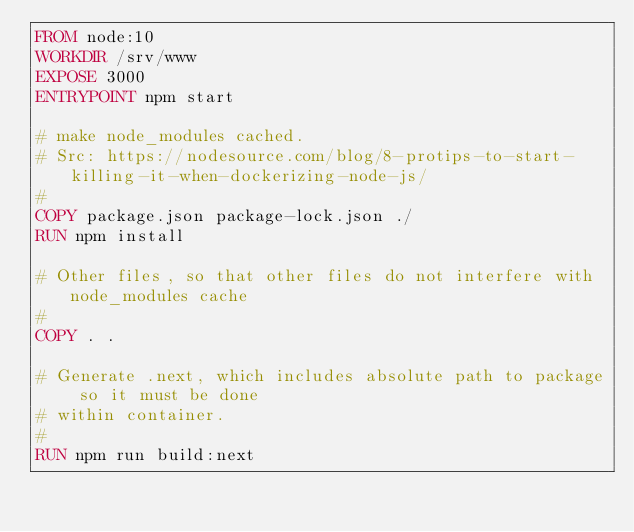Convert code to text. <code><loc_0><loc_0><loc_500><loc_500><_Dockerfile_>FROM node:10
WORKDIR /srv/www
EXPOSE 3000
ENTRYPOINT npm start

# make node_modules cached.
# Src: https://nodesource.com/blog/8-protips-to-start-killing-it-when-dockerizing-node-js/
#
COPY package.json package-lock.json ./
RUN npm install

# Other files, so that other files do not interfere with node_modules cache
#
COPY . .

# Generate .next, which includes absolute path to package so it must be done
# within container.
#
RUN npm run build:next
</code> 